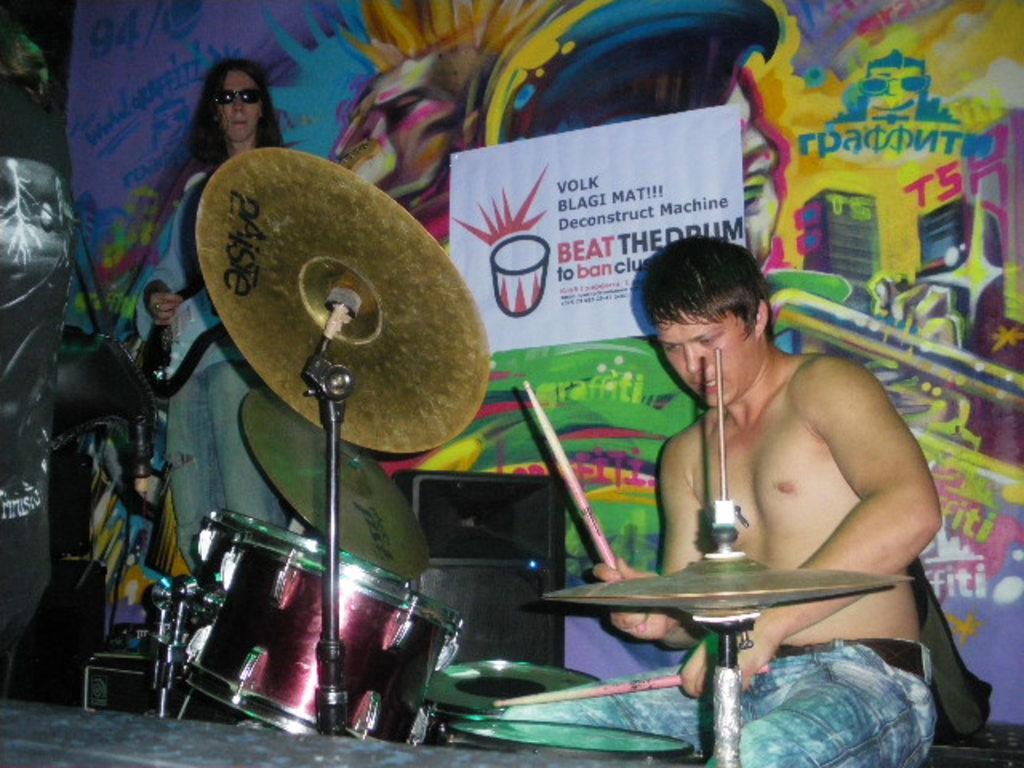Describe this image in one or two sentences. Here we can see a man sitting on a chair and playing drums and on the left side we can see a man standing and playing a guitar behind both of them there is a colorful poster 